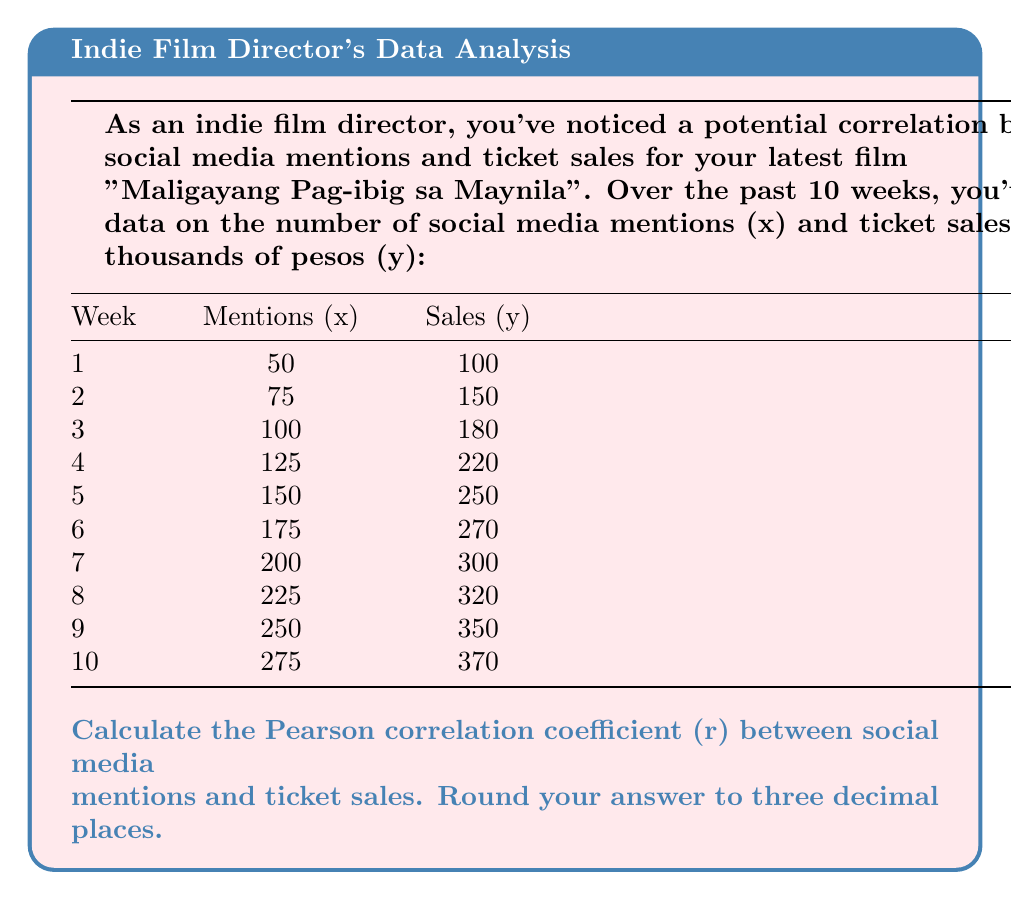Show me your answer to this math problem. To calculate the Pearson correlation coefficient (r), we'll use the formula:

$$ r = \frac{n\sum xy - (\sum x)(\sum y)}{\sqrt{[n\sum x^2 - (\sum x)^2][n\sum y^2 - (\sum y)^2]}} $$

Where:
n = number of data points
x = social media mentions
y = ticket sales in thousands of pesos

Step 1: Calculate the required sums:
n = 10
$\sum x = 1625$
$\sum y = 2510$
$\sum xy = 451,250$
$\sum x^2 = 306,250$
$\sum y^2 = 679,700$

Step 2: Substitute these values into the formula:

$$ r = \frac{10(451,250) - (1625)(2510)}{\sqrt{[10(306,250) - 1625^2][10(679,700) - 2510^2]}} $$

Step 3: Simplify:

$$ r = \frac{4,512,500 - 4,078,750}{\sqrt{(3,062,500 - 2,640,625)(6,797,000 - 6,300,100)}} $$

$$ r = \frac{433,750}{\sqrt{(421,875)(496,900)}} $$

$$ r = \frac{433,750}{\sqrt{209,629,687,500}} $$

$$ r = \frac{433,750}{457,852.97} $$

$$ r \approx 0.947 $$
Answer: 0.947 